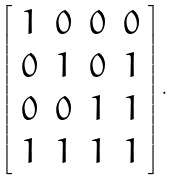Convert formula to latex. <formula><loc_0><loc_0><loc_500><loc_500>\left [ \begin{array} { c c c c } 1 & 0 & 0 & 0 \\ 0 & 1 & 0 & 1 \\ 0 & 0 & 1 & 1 \\ 1 & 1 & 1 & 1 \end{array} \right ] .</formula> 